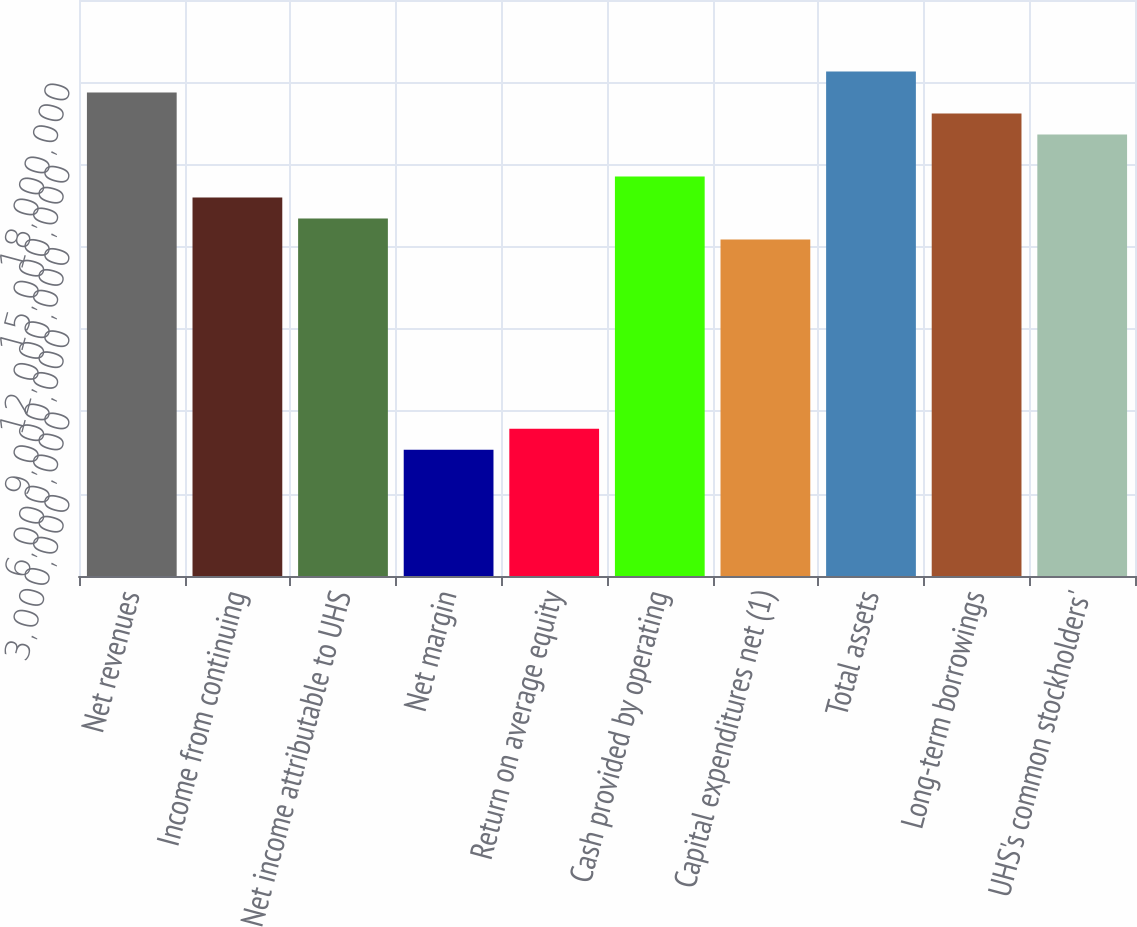Convert chart to OTSL. <chart><loc_0><loc_0><loc_500><loc_500><bar_chart><fcel>Net revenues<fcel>Income from continuing<fcel>Net income attributable to UHS<fcel>Net margin<fcel>Return on average equity<fcel>Cash provided by operating<fcel>Capital expenditures net (1)<fcel>Total assets<fcel>Long-term borrowings<fcel>UHS's common stockholders'<nl><fcel>1.76301e+07<fcel>1.37974e+07<fcel>1.30309e+07<fcel>4.59915e+06<fcel>5.36567e+06<fcel>1.4564e+07<fcel>1.22644e+07<fcel>1.83966e+07<fcel>1.68635e+07<fcel>1.6097e+07<nl></chart> 